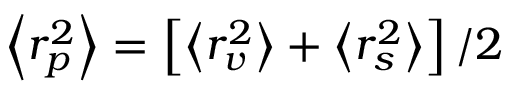Convert formula to latex. <formula><loc_0><loc_0><loc_500><loc_500>\left < r _ { p } ^ { 2 } \right > = \left [ \left < r _ { v } ^ { 2 } \right > + \left < r _ { s } ^ { 2 } \right > \right ] / 2</formula> 